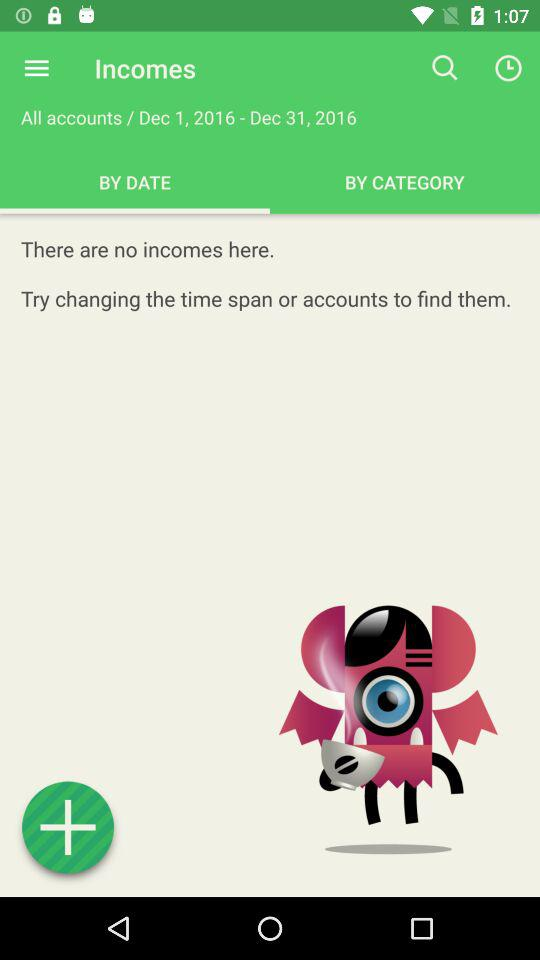What are the expenses?
When the provided information is insufficient, respond with <no answer>. <no answer> 